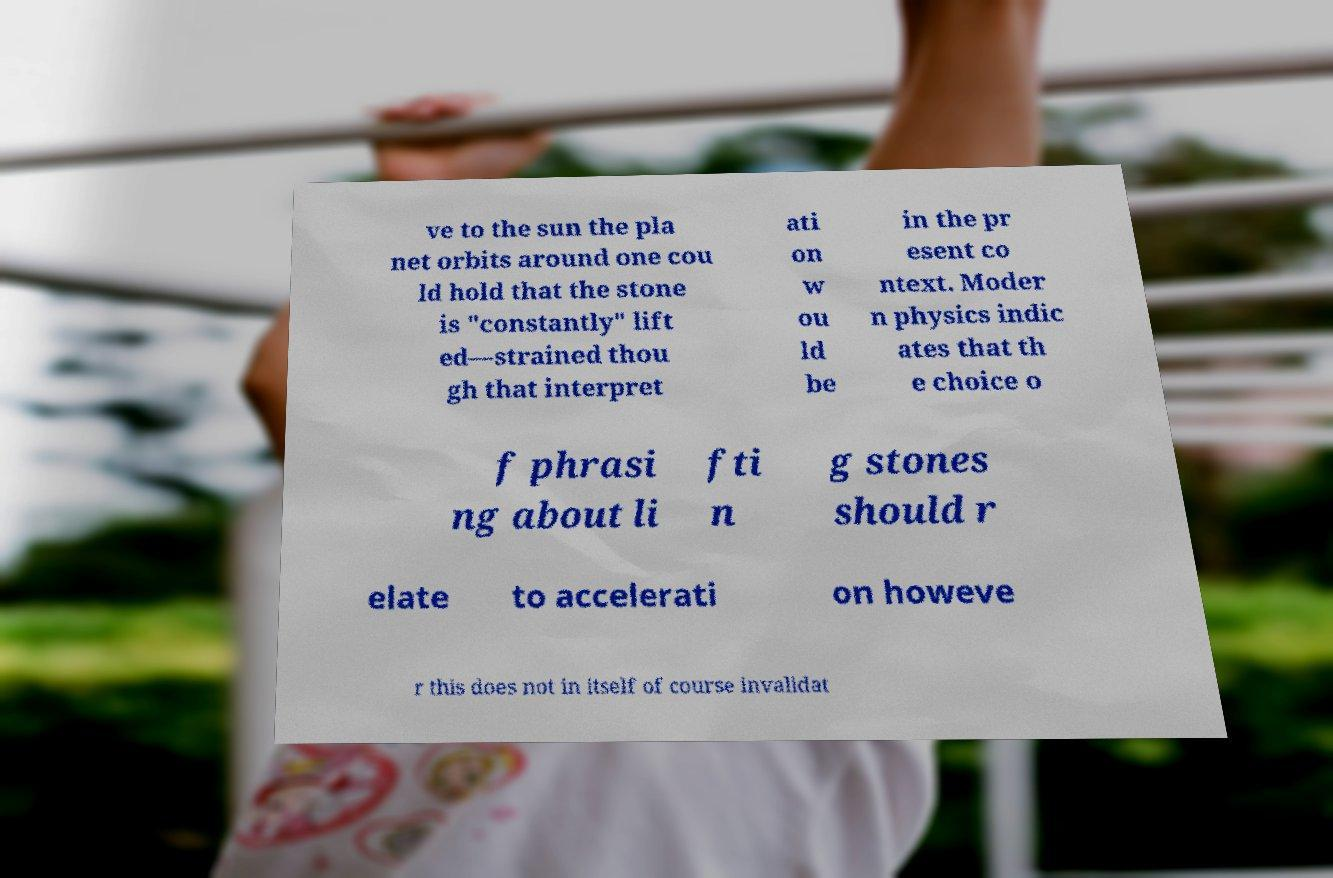Please identify and transcribe the text found in this image. ve to the sun the pla net orbits around one cou ld hold that the stone is "constantly" lift ed—strained thou gh that interpret ati on w ou ld be in the pr esent co ntext. Moder n physics indic ates that th e choice o f phrasi ng about li fti n g stones should r elate to accelerati on howeve r this does not in itself of course invalidat 